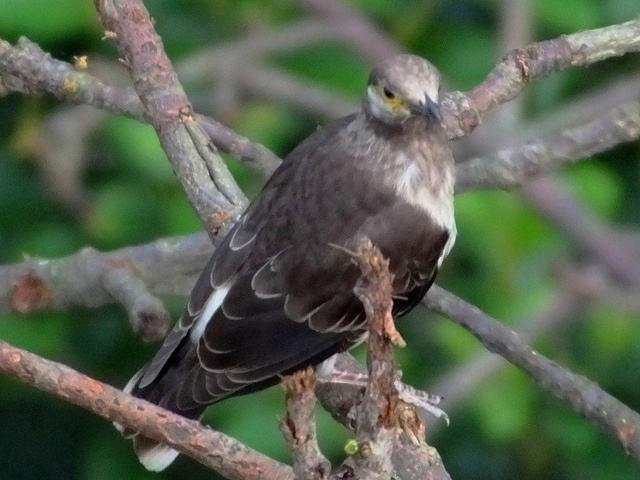Describe the objects in this image and their specific colors. I can see a bird in green, black, gray, and darkgray tones in this image. 